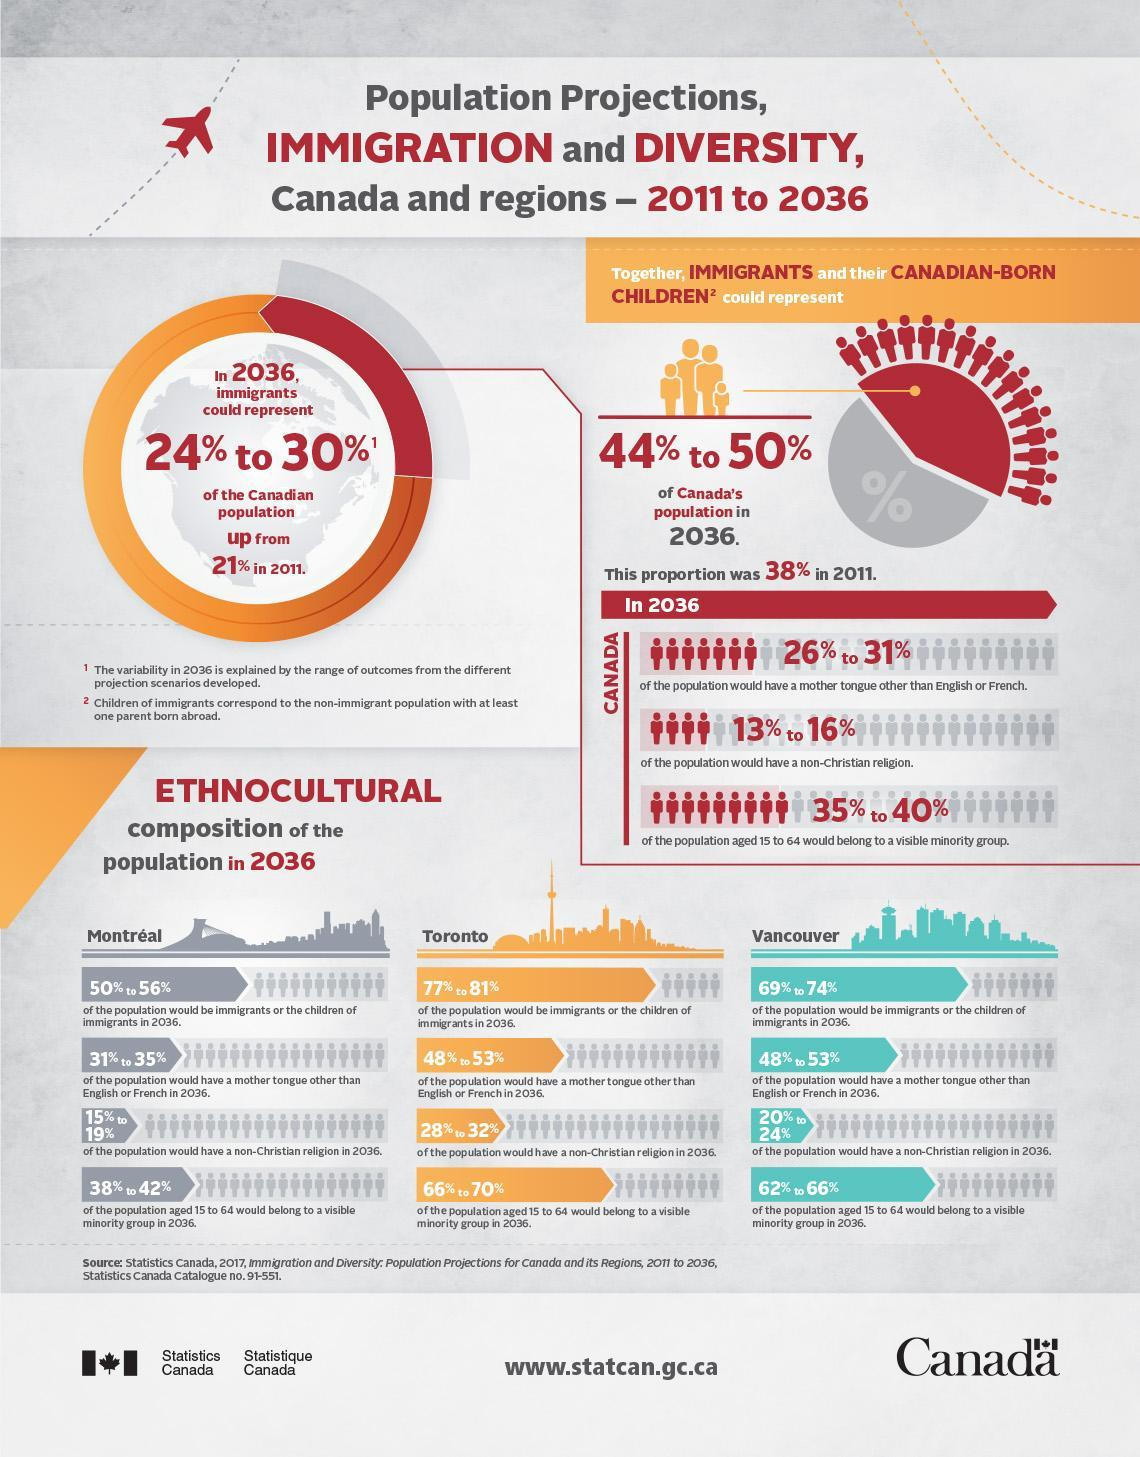What percentage of Vancouver's population would be immigrants or the children of immigrants in 2011?
Answer the question with a short phrase. 69% to 74% What percentage of Canada's population were immigrants or the children of immigrants in 2011? 38% What percentage of Montreal's population would have a non-christian religion in 2036? 15% to 19% What percentage of Toronto's population would have a mother tongue other than english or french in 2036? 48% to 53% What percentage of Toronto's population aged 15-64 years would belong to a visible minority group in 2036? 66% to 70% 